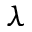Convert formula to latex. <formula><loc_0><loc_0><loc_500><loc_500>\lambda</formula> 